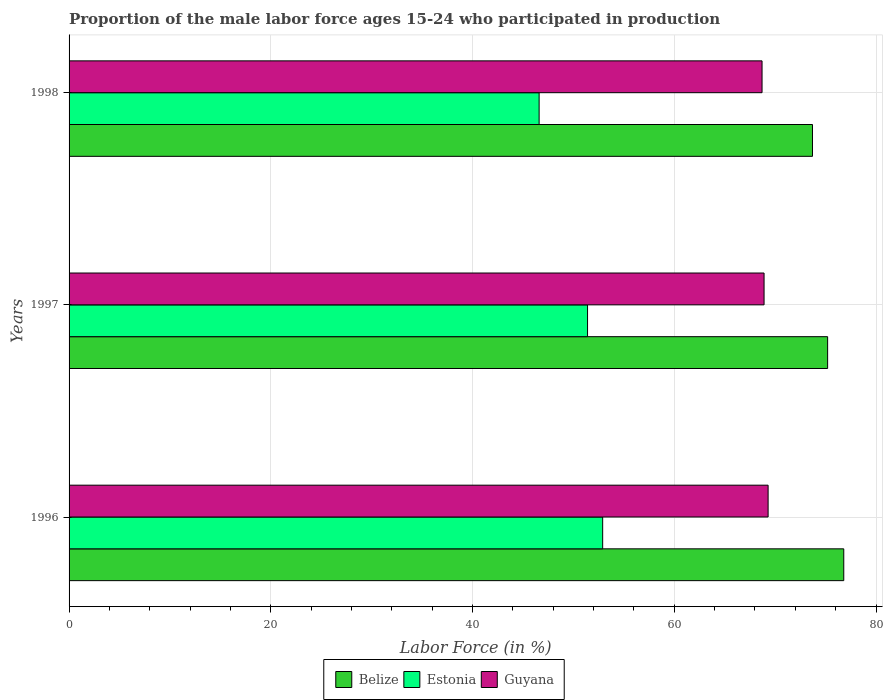How many groups of bars are there?
Give a very brief answer. 3. How many bars are there on the 3rd tick from the bottom?
Keep it short and to the point. 3. What is the label of the 1st group of bars from the top?
Your response must be concise. 1998. In how many cases, is the number of bars for a given year not equal to the number of legend labels?
Provide a succinct answer. 0. What is the proportion of the male labor force who participated in production in Estonia in 1996?
Ensure brevity in your answer.  52.9. Across all years, what is the maximum proportion of the male labor force who participated in production in Estonia?
Your answer should be very brief. 52.9. Across all years, what is the minimum proportion of the male labor force who participated in production in Estonia?
Provide a succinct answer. 46.6. In which year was the proportion of the male labor force who participated in production in Guyana maximum?
Make the answer very short. 1996. In which year was the proportion of the male labor force who participated in production in Guyana minimum?
Ensure brevity in your answer.  1998. What is the total proportion of the male labor force who participated in production in Estonia in the graph?
Make the answer very short. 150.9. What is the difference between the proportion of the male labor force who participated in production in Estonia in 1997 and that in 1998?
Offer a terse response. 4.8. What is the difference between the proportion of the male labor force who participated in production in Belize in 1998 and the proportion of the male labor force who participated in production in Guyana in 1997?
Give a very brief answer. 4.8. What is the average proportion of the male labor force who participated in production in Belize per year?
Provide a succinct answer. 75.23. In how many years, is the proportion of the male labor force who participated in production in Guyana greater than 44 %?
Offer a very short reply. 3. What is the ratio of the proportion of the male labor force who participated in production in Belize in 1996 to that in 1997?
Give a very brief answer. 1.02. What is the difference between the highest and the second highest proportion of the male labor force who participated in production in Estonia?
Make the answer very short. 1.5. What is the difference between the highest and the lowest proportion of the male labor force who participated in production in Belize?
Provide a succinct answer. 3.1. In how many years, is the proportion of the male labor force who participated in production in Guyana greater than the average proportion of the male labor force who participated in production in Guyana taken over all years?
Offer a terse response. 1. What does the 2nd bar from the top in 1996 represents?
Make the answer very short. Estonia. What does the 1st bar from the bottom in 1997 represents?
Provide a succinct answer. Belize. How many bars are there?
Give a very brief answer. 9. Are all the bars in the graph horizontal?
Ensure brevity in your answer.  Yes. Are the values on the major ticks of X-axis written in scientific E-notation?
Offer a terse response. No. Does the graph contain any zero values?
Keep it short and to the point. No. Does the graph contain grids?
Your response must be concise. Yes. Where does the legend appear in the graph?
Your answer should be compact. Bottom center. What is the title of the graph?
Give a very brief answer. Proportion of the male labor force ages 15-24 who participated in production. Does "Iceland" appear as one of the legend labels in the graph?
Your answer should be very brief. No. What is the label or title of the X-axis?
Your answer should be compact. Labor Force (in %). What is the Labor Force (in %) in Belize in 1996?
Make the answer very short. 76.8. What is the Labor Force (in %) of Estonia in 1996?
Your answer should be very brief. 52.9. What is the Labor Force (in %) in Guyana in 1996?
Provide a short and direct response. 69.3. What is the Labor Force (in %) in Belize in 1997?
Ensure brevity in your answer.  75.2. What is the Labor Force (in %) in Estonia in 1997?
Give a very brief answer. 51.4. What is the Labor Force (in %) in Guyana in 1997?
Provide a succinct answer. 68.9. What is the Labor Force (in %) in Belize in 1998?
Give a very brief answer. 73.7. What is the Labor Force (in %) of Estonia in 1998?
Provide a succinct answer. 46.6. What is the Labor Force (in %) in Guyana in 1998?
Provide a short and direct response. 68.7. Across all years, what is the maximum Labor Force (in %) of Belize?
Your answer should be compact. 76.8. Across all years, what is the maximum Labor Force (in %) in Estonia?
Offer a terse response. 52.9. Across all years, what is the maximum Labor Force (in %) in Guyana?
Your response must be concise. 69.3. Across all years, what is the minimum Labor Force (in %) in Belize?
Give a very brief answer. 73.7. Across all years, what is the minimum Labor Force (in %) in Estonia?
Give a very brief answer. 46.6. Across all years, what is the minimum Labor Force (in %) in Guyana?
Provide a short and direct response. 68.7. What is the total Labor Force (in %) in Belize in the graph?
Your answer should be compact. 225.7. What is the total Labor Force (in %) of Estonia in the graph?
Keep it short and to the point. 150.9. What is the total Labor Force (in %) in Guyana in the graph?
Provide a succinct answer. 206.9. What is the difference between the Labor Force (in %) in Belize in 1996 and that in 1997?
Your answer should be very brief. 1.6. What is the difference between the Labor Force (in %) in Estonia in 1996 and that in 1997?
Make the answer very short. 1.5. What is the difference between the Labor Force (in %) of Guyana in 1996 and that in 1998?
Make the answer very short. 0.6. What is the difference between the Labor Force (in %) in Guyana in 1997 and that in 1998?
Provide a short and direct response. 0.2. What is the difference between the Labor Force (in %) of Belize in 1996 and the Labor Force (in %) of Estonia in 1997?
Keep it short and to the point. 25.4. What is the difference between the Labor Force (in %) in Belize in 1996 and the Labor Force (in %) in Estonia in 1998?
Provide a short and direct response. 30.2. What is the difference between the Labor Force (in %) of Estonia in 1996 and the Labor Force (in %) of Guyana in 1998?
Give a very brief answer. -15.8. What is the difference between the Labor Force (in %) in Belize in 1997 and the Labor Force (in %) in Estonia in 1998?
Provide a succinct answer. 28.6. What is the difference between the Labor Force (in %) in Belize in 1997 and the Labor Force (in %) in Guyana in 1998?
Give a very brief answer. 6.5. What is the difference between the Labor Force (in %) in Estonia in 1997 and the Labor Force (in %) in Guyana in 1998?
Your answer should be very brief. -17.3. What is the average Labor Force (in %) in Belize per year?
Provide a succinct answer. 75.23. What is the average Labor Force (in %) of Estonia per year?
Provide a succinct answer. 50.3. What is the average Labor Force (in %) of Guyana per year?
Offer a terse response. 68.97. In the year 1996, what is the difference between the Labor Force (in %) of Belize and Labor Force (in %) of Estonia?
Keep it short and to the point. 23.9. In the year 1996, what is the difference between the Labor Force (in %) of Belize and Labor Force (in %) of Guyana?
Provide a short and direct response. 7.5. In the year 1996, what is the difference between the Labor Force (in %) of Estonia and Labor Force (in %) of Guyana?
Make the answer very short. -16.4. In the year 1997, what is the difference between the Labor Force (in %) in Belize and Labor Force (in %) in Estonia?
Keep it short and to the point. 23.8. In the year 1997, what is the difference between the Labor Force (in %) of Belize and Labor Force (in %) of Guyana?
Your answer should be compact. 6.3. In the year 1997, what is the difference between the Labor Force (in %) of Estonia and Labor Force (in %) of Guyana?
Your answer should be compact. -17.5. In the year 1998, what is the difference between the Labor Force (in %) of Belize and Labor Force (in %) of Estonia?
Offer a terse response. 27.1. In the year 1998, what is the difference between the Labor Force (in %) of Estonia and Labor Force (in %) of Guyana?
Give a very brief answer. -22.1. What is the ratio of the Labor Force (in %) of Belize in 1996 to that in 1997?
Ensure brevity in your answer.  1.02. What is the ratio of the Labor Force (in %) in Estonia in 1996 to that in 1997?
Ensure brevity in your answer.  1.03. What is the ratio of the Labor Force (in %) in Belize in 1996 to that in 1998?
Your answer should be compact. 1.04. What is the ratio of the Labor Force (in %) of Estonia in 1996 to that in 1998?
Keep it short and to the point. 1.14. What is the ratio of the Labor Force (in %) in Guyana in 1996 to that in 1998?
Give a very brief answer. 1.01. What is the ratio of the Labor Force (in %) in Belize in 1997 to that in 1998?
Offer a terse response. 1.02. What is the ratio of the Labor Force (in %) of Estonia in 1997 to that in 1998?
Provide a short and direct response. 1.1. What is the difference between the highest and the second highest Labor Force (in %) in Guyana?
Your answer should be very brief. 0.4. What is the difference between the highest and the lowest Labor Force (in %) in Belize?
Your response must be concise. 3.1. 